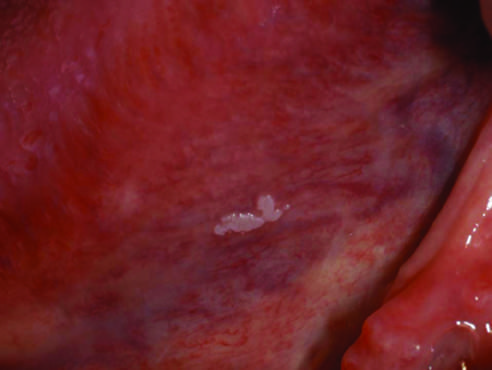s the wall of the artery highly variable?
Answer the question using a single word or phrase. No 